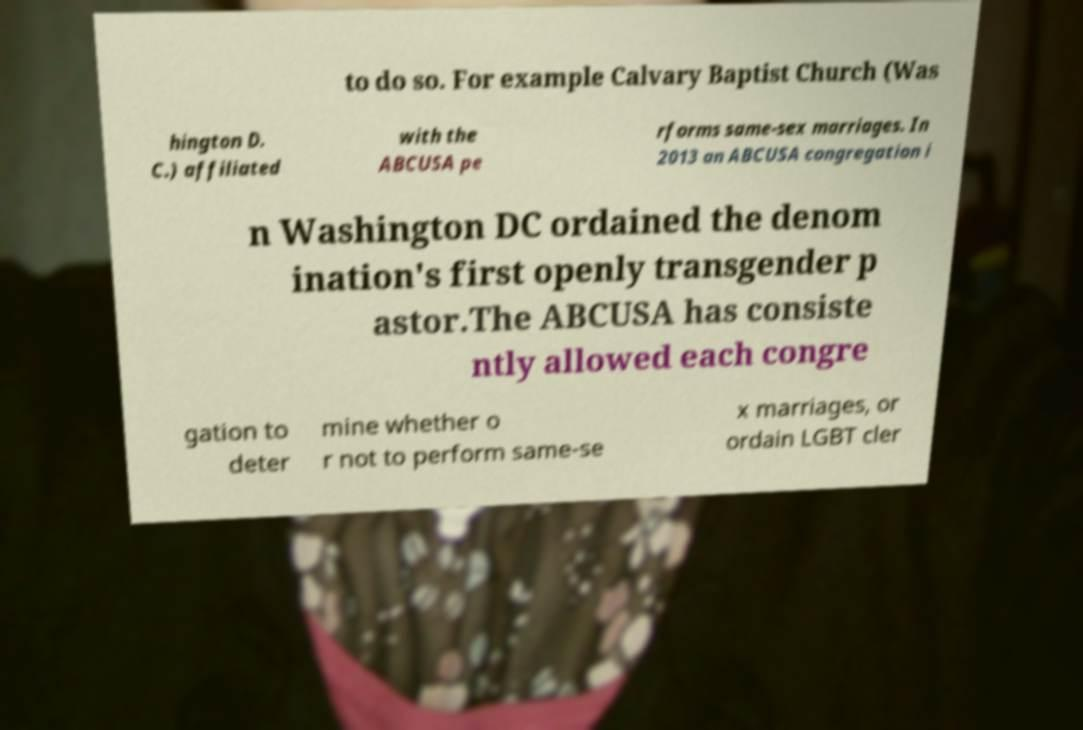Could you assist in decoding the text presented in this image and type it out clearly? to do so. For example Calvary Baptist Church (Was hington D. C.) affiliated with the ABCUSA pe rforms same-sex marriages. In 2013 an ABCUSA congregation i n Washington DC ordained the denom ination's first openly transgender p astor.The ABCUSA has consiste ntly allowed each congre gation to deter mine whether o r not to perform same-se x marriages, or ordain LGBT cler 